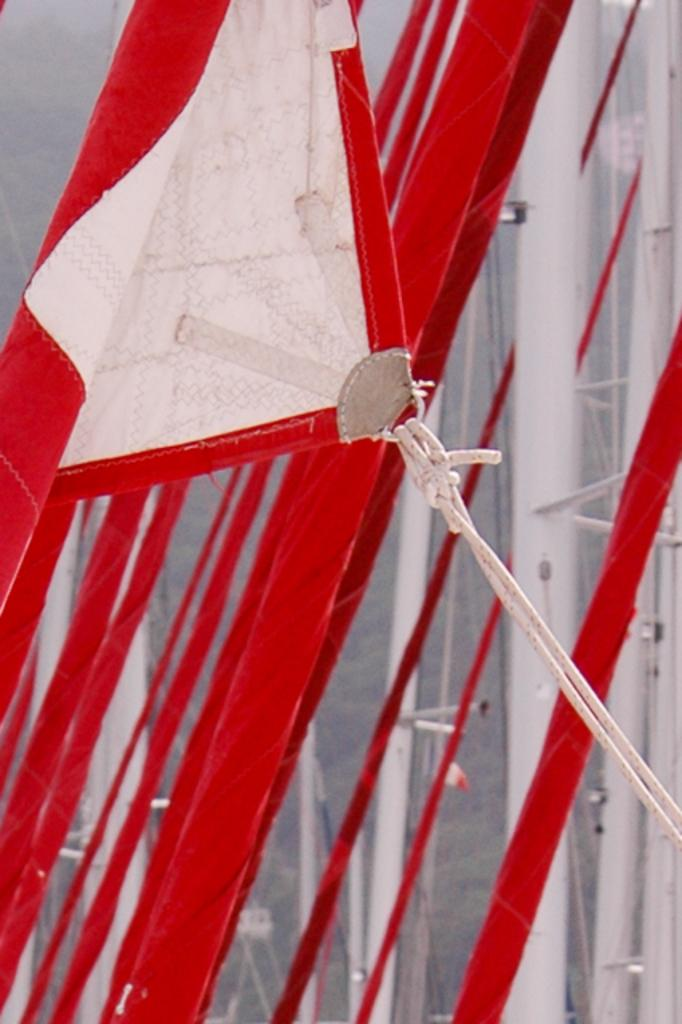What is hanging in the image? There is a banner in the image. How is the banner secured? The banner is tied with ropes. What can be seen in the background of the image? There are poles and trees in the background of the image. What song is being sung by the banner in the image? There is no indication that the banner is singing a song in the image. 